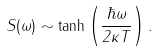Convert formula to latex. <formula><loc_0><loc_0><loc_500><loc_500>S ( \omega ) \sim \tanh \left ( \frac { \hbar { \omega } } { 2 \kappa T } \right ) .</formula> 